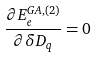<formula> <loc_0><loc_0><loc_500><loc_500>\frac { \partial E _ { e } ^ { G A , ( 2 ) } } { \partial \delta D _ { q } } = 0</formula> 